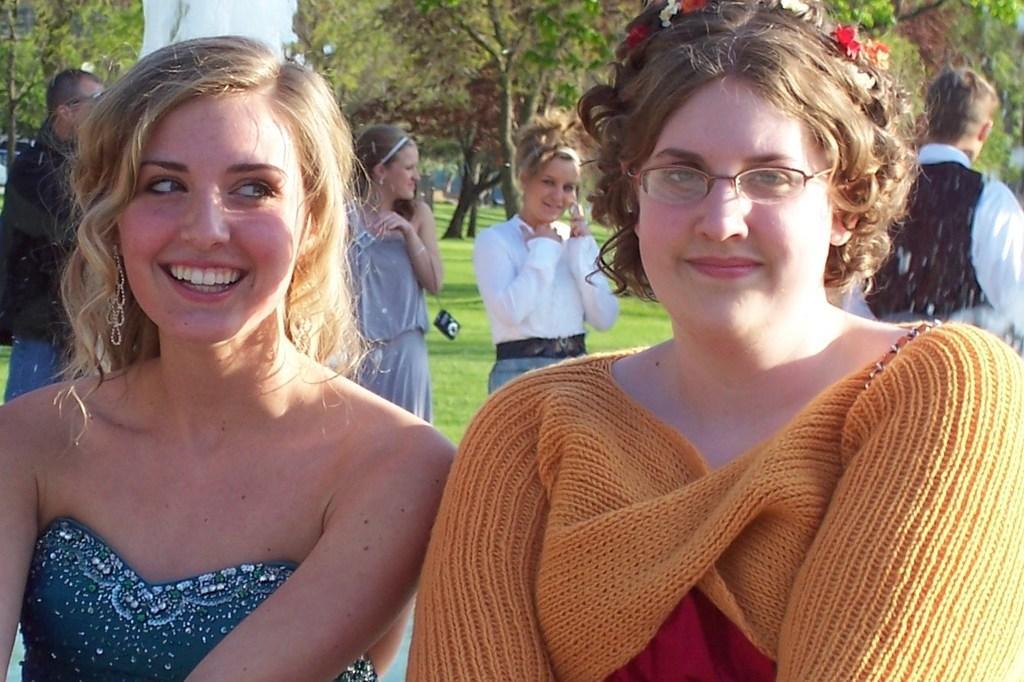How would you summarize this image in a sentence or two? Front these two people are smiling. This woman wore spectacles. Background we can see grass, people and trees. Near this person there is a camera. 